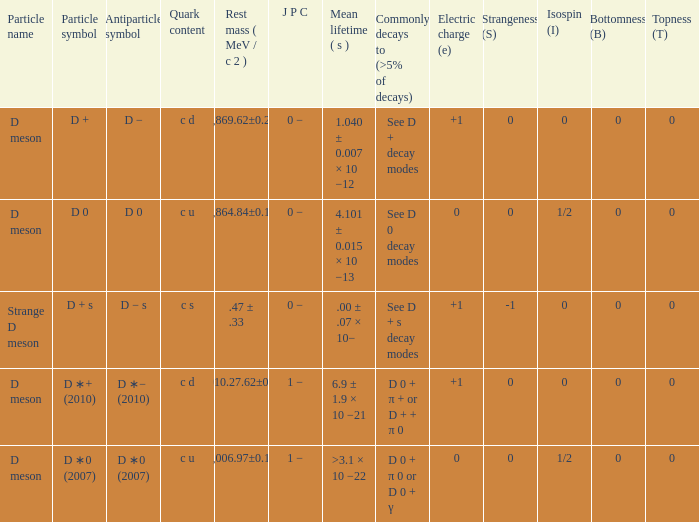What is the j p c that commonly decays (>5% of decays) d 0 + π 0 or d 0 + γ? 1 −. 